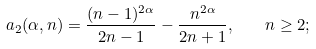Convert formula to latex. <formula><loc_0><loc_0><loc_500><loc_500>a _ { 2 } ( \alpha , n ) = \frac { ( n - 1 ) ^ { 2 \alpha } } { 2 n - 1 } - \frac { n ^ { 2 \alpha } } { 2 n + 1 } , \quad n \geq 2 ;</formula> 